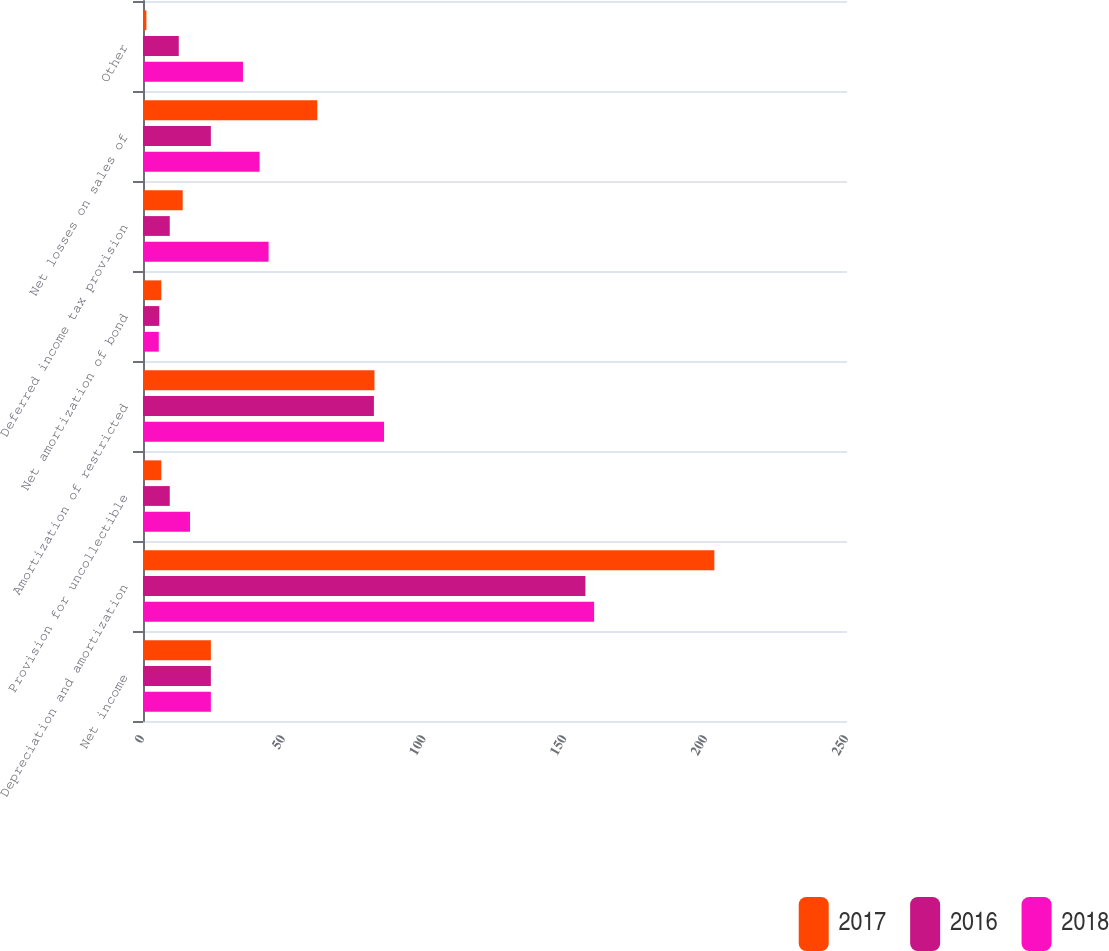<chart> <loc_0><loc_0><loc_500><loc_500><stacked_bar_chart><ecel><fcel>Net income<fcel>Depreciation and amortization<fcel>Provision for uncollectible<fcel>Amortization of restricted<fcel>Net amortization of bond<fcel>Deferred income tax provision<fcel>Net losses on sales of<fcel>Other<nl><fcel>2017<fcel>24.1<fcel>202.9<fcel>6.5<fcel>82.2<fcel>6.5<fcel>14.1<fcel>61.9<fcel>1.2<nl><fcel>2016<fcel>24.1<fcel>157.1<fcel>9.5<fcel>82<fcel>5.8<fcel>9.5<fcel>24.1<fcel>12.7<nl><fcel>2018<fcel>24.1<fcel>160.2<fcel>16.7<fcel>85.6<fcel>5.6<fcel>44.6<fcel>41.4<fcel>35.5<nl></chart> 